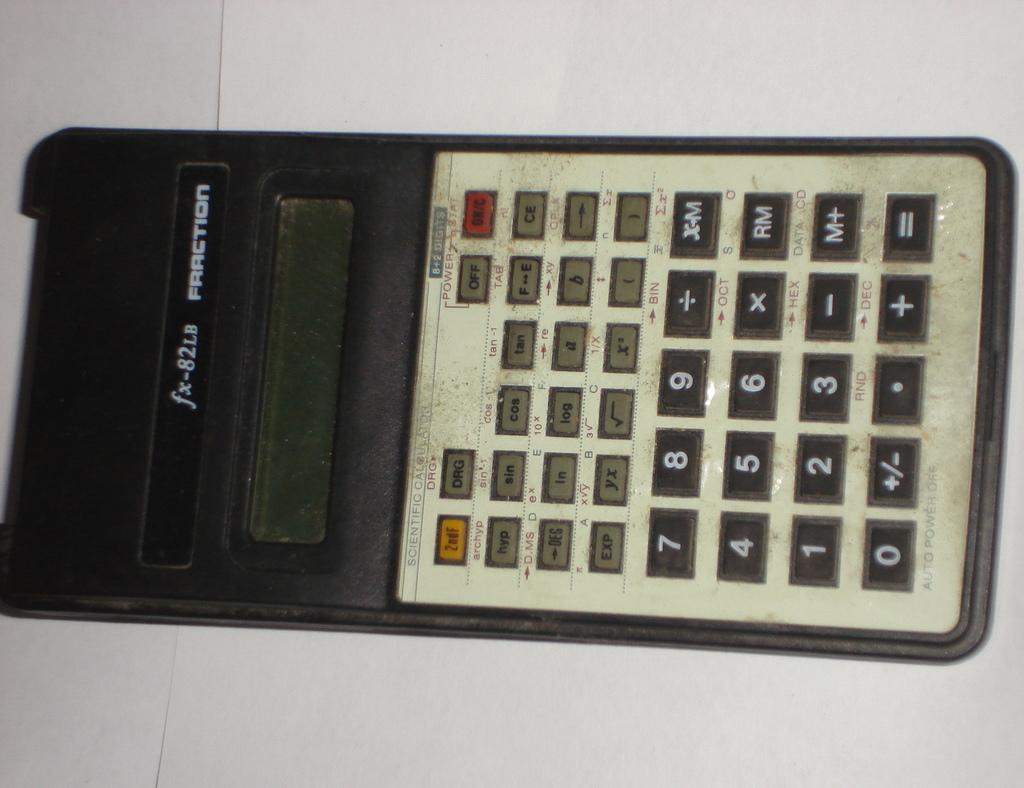<image>
Provide a brief description of the given image. The black and silver calculator is a fx 82lb model 